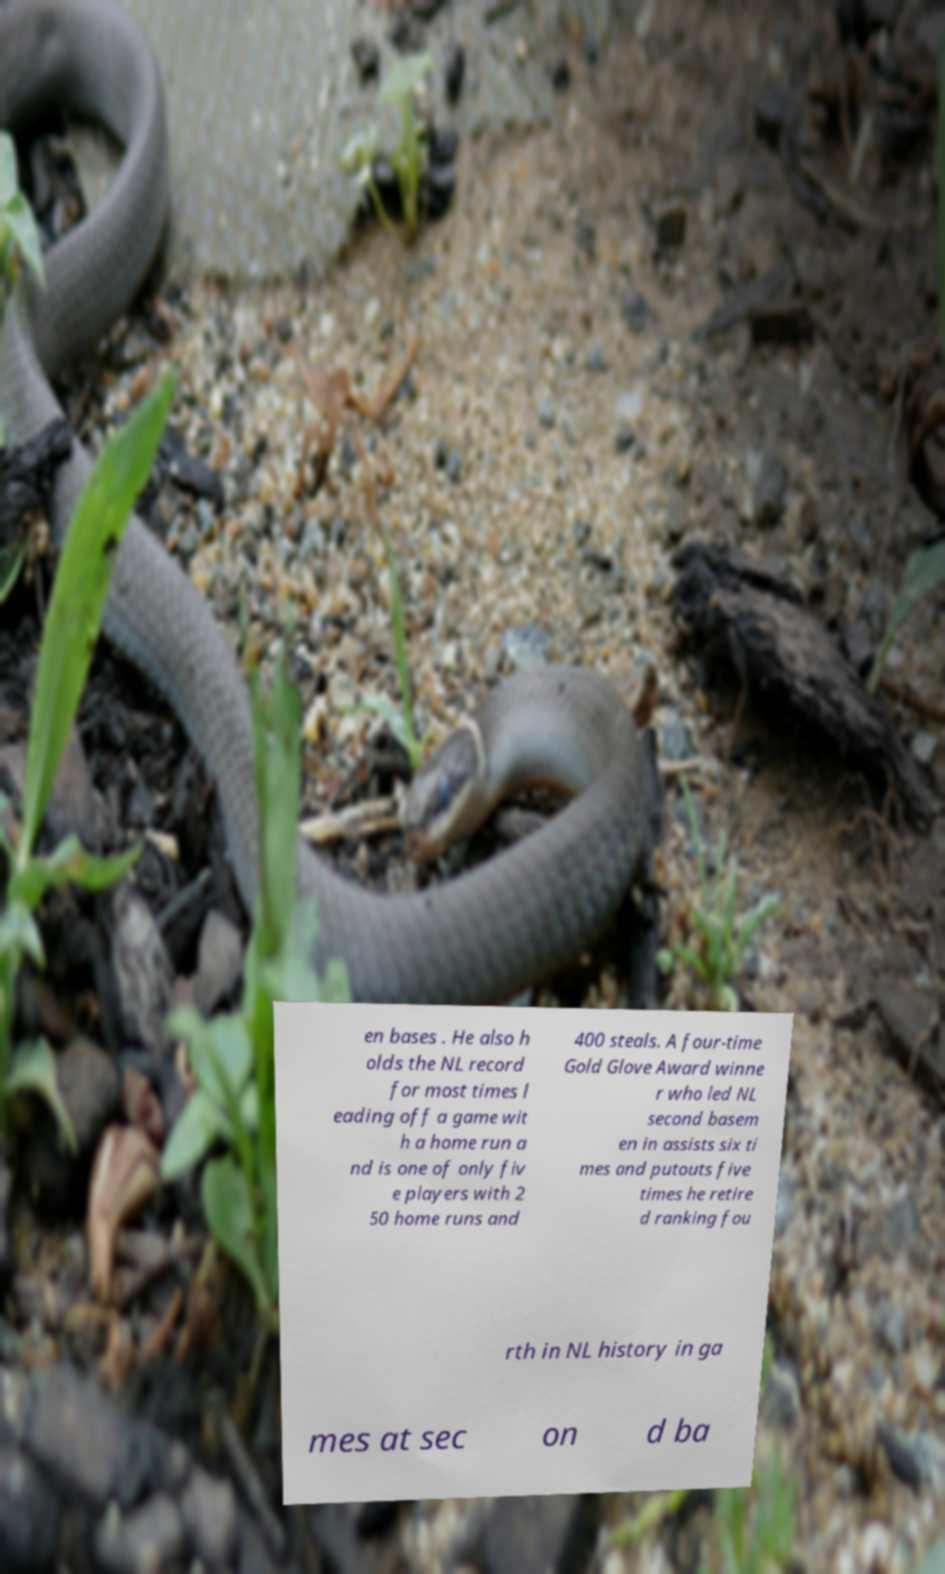Please identify and transcribe the text found in this image. en bases . He also h olds the NL record for most times l eading off a game wit h a home run a nd is one of only fiv e players with 2 50 home runs and 400 steals. A four-time Gold Glove Award winne r who led NL second basem en in assists six ti mes and putouts five times he retire d ranking fou rth in NL history in ga mes at sec on d ba 